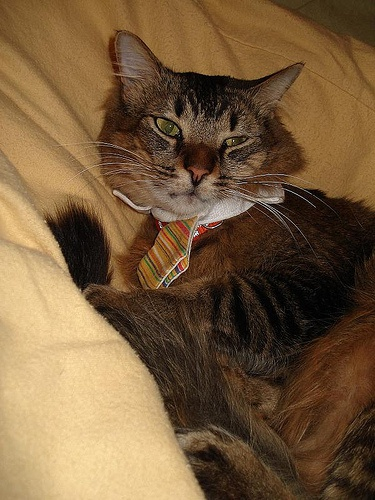Describe the objects in this image and their specific colors. I can see bed in maroon, olive, and tan tones, couch in maroon, olive, and tan tones, cat in maroon, black, and gray tones, cat in maroon, black, and gray tones, and tie in maroon, olive, and gray tones in this image. 